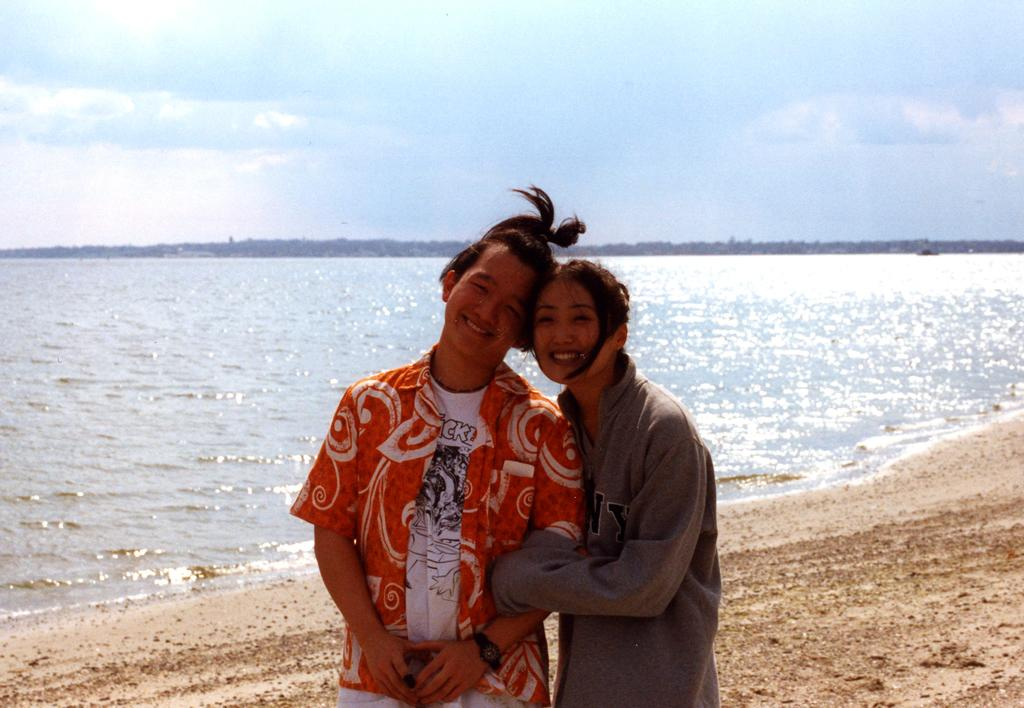How many people are in the image? There are two people in the image, a man and a woman. What are the man and woman doing in the image? The man and woman are standing together and smiling. What can be seen in the background of the image? Water and sky are visible in the background of the image. What type of card is the man holding in the image? There is no card present in the image; the man is not holding anything. What kind of map can be seen in the image? There is no map present in the image; the focus is on the man and woman standing together. 